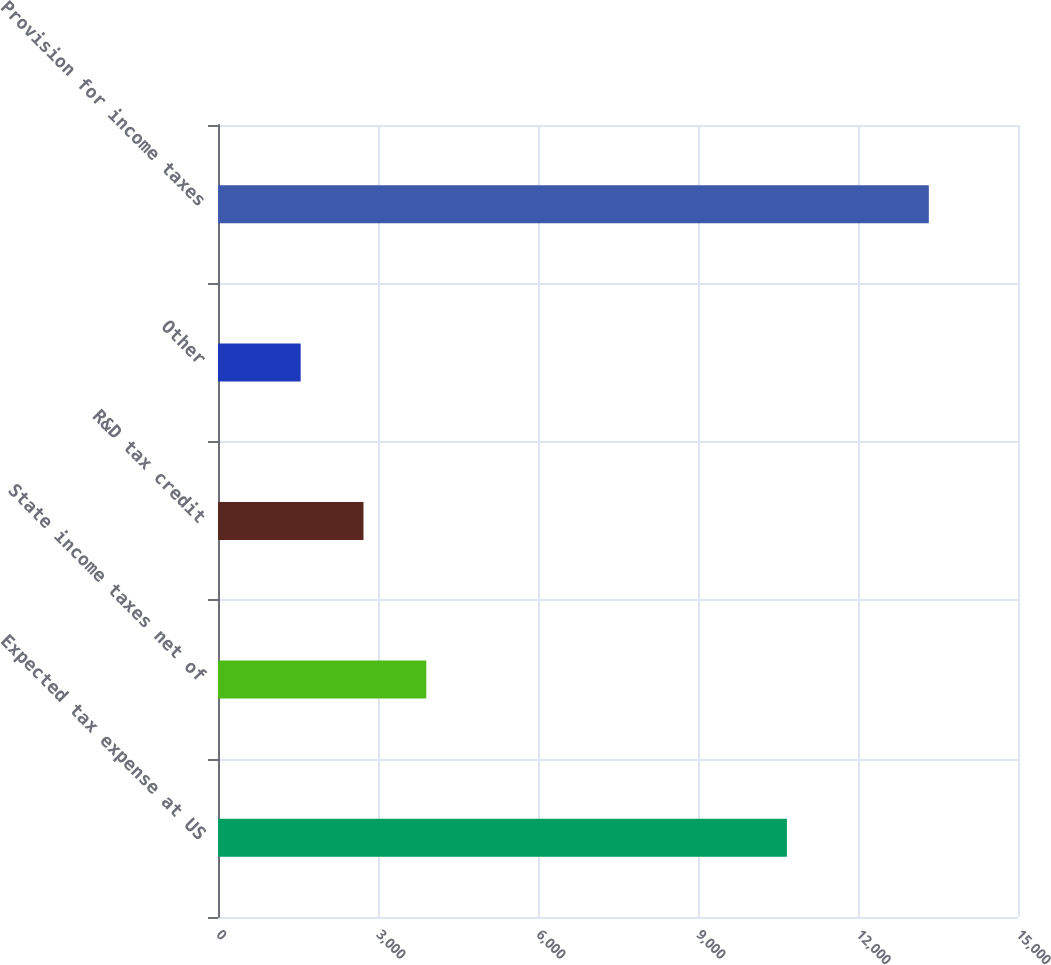<chart> <loc_0><loc_0><loc_500><loc_500><bar_chart><fcel>Expected tax expense at US<fcel>State income taxes net of<fcel>R&D tax credit<fcel>Other<fcel>Provision for income taxes<nl><fcel>10667<fcel>3905.6<fcel>2727.8<fcel>1550<fcel>13328<nl></chart> 